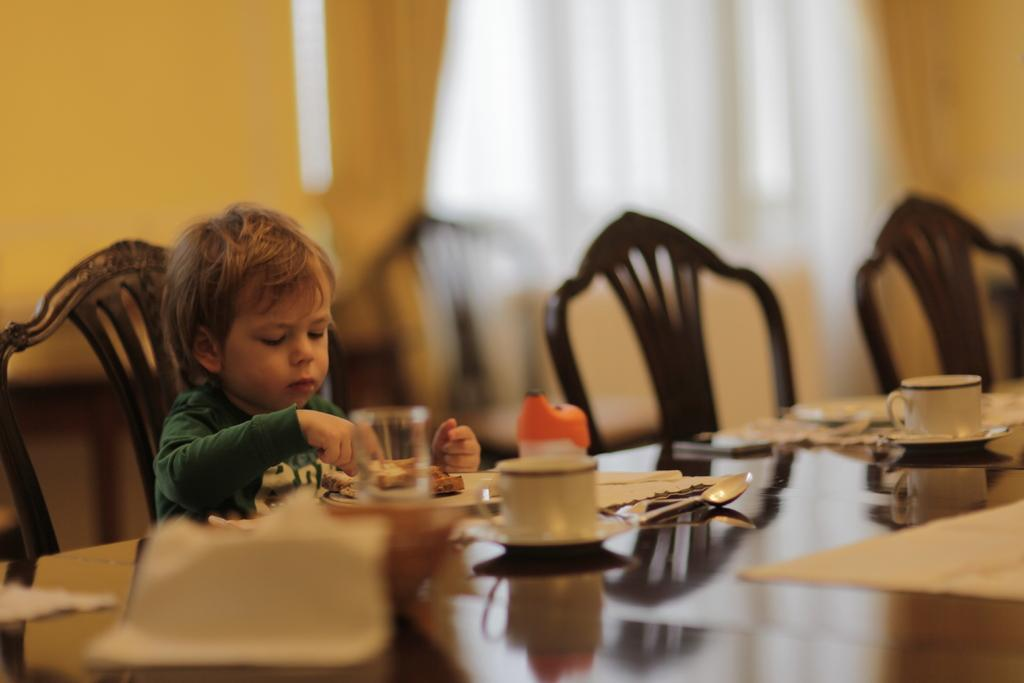Who is the main subject in the image? There is a boy in the image. What is the boy doing in the image? The boy is sitting on a chair and eating. What is in front of the boy? There is a table in front of the boy. What can be seen on the table? There are plates and objects on the table. What type of insect is crawling on the boy's throat in the image? There is no insect present on the boy's throat in the image. How is the boy using the hose to eat in the image? There is no hose present in the image; the boy is using a fork or spoon to eat. 